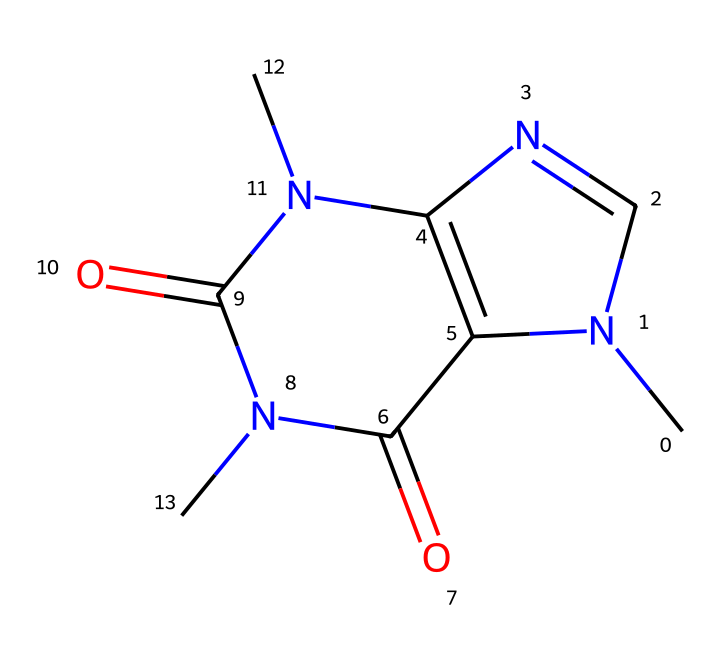How many nitrogen atoms are present in this chemical structure? By examining the SMILES representation, we can see that there are two nitrogen atoms (N) indicated in the structure.
Answer: 2 What is the functional group present in this compound? The presence of the carbonyl (C=O) groups is visible in the structure, which indicates that the compound has amide functional groups as it connects to nitrogen atoms.
Answer: amide What is the total number of rings in this structure? Analyzing the SMILES representation, we can identify two distinct ring structures present in the compound.
Answer: 2 Is this compound aromatic? The rings present in the structure do not contain alternating double bonds or fulfill the criteria for aromaticity, thus this compound is not aromatic.
Answer: no What is the molecular formula of caffeine? By determining the number of each type of atom (C, H, N, O) in the structure, we find the molecular formula is C8H10N4O2.
Answer: C8H10N4O2 Which types of bonding are present in this chemical? Looking at the structure, there are single bonds, double bonds, and bonding to nitrogen atoms, indicating covalent bonding throughout the compound.
Answer: covalent What is the primary effect of caffeine consumption? This compound is known to stimulate the central nervous system, enhancing alertness and concentration, which is particularly beneficial for programmers.
Answer: stimulant 